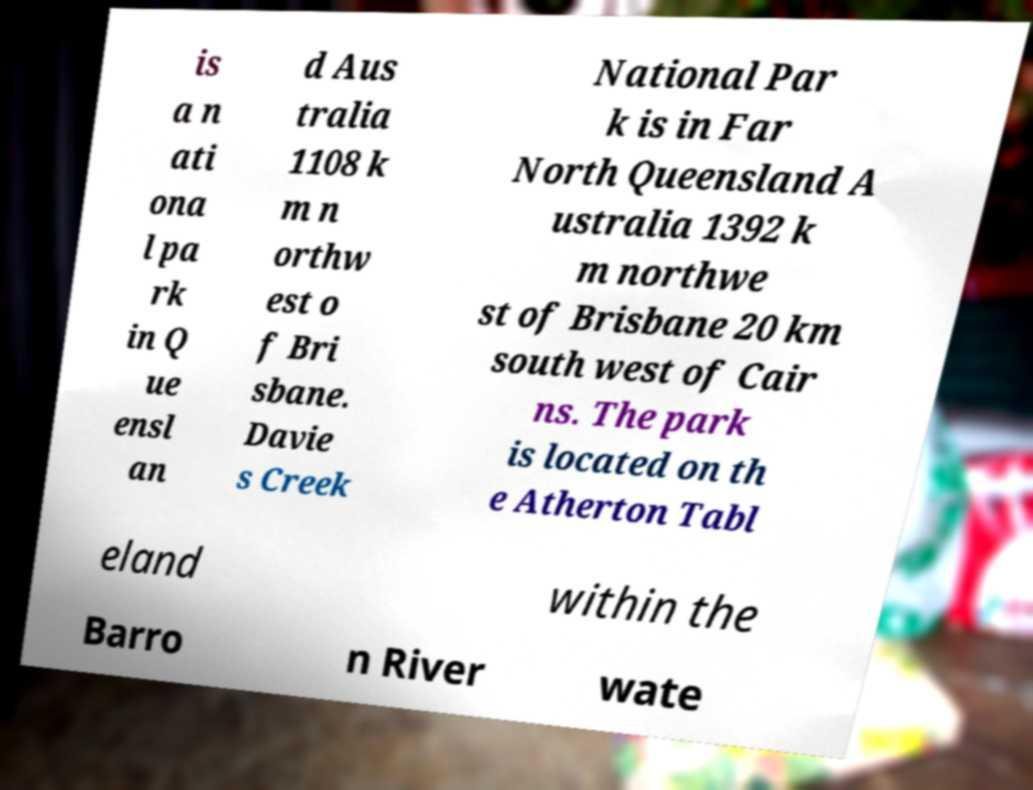I need the written content from this picture converted into text. Can you do that? is a n ati ona l pa rk in Q ue ensl an d Aus tralia 1108 k m n orthw est o f Bri sbane. Davie s Creek National Par k is in Far North Queensland A ustralia 1392 k m northwe st of Brisbane 20 km south west of Cair ns. The park is located on th e Atherton Tabl eland within the Barro n River wate 